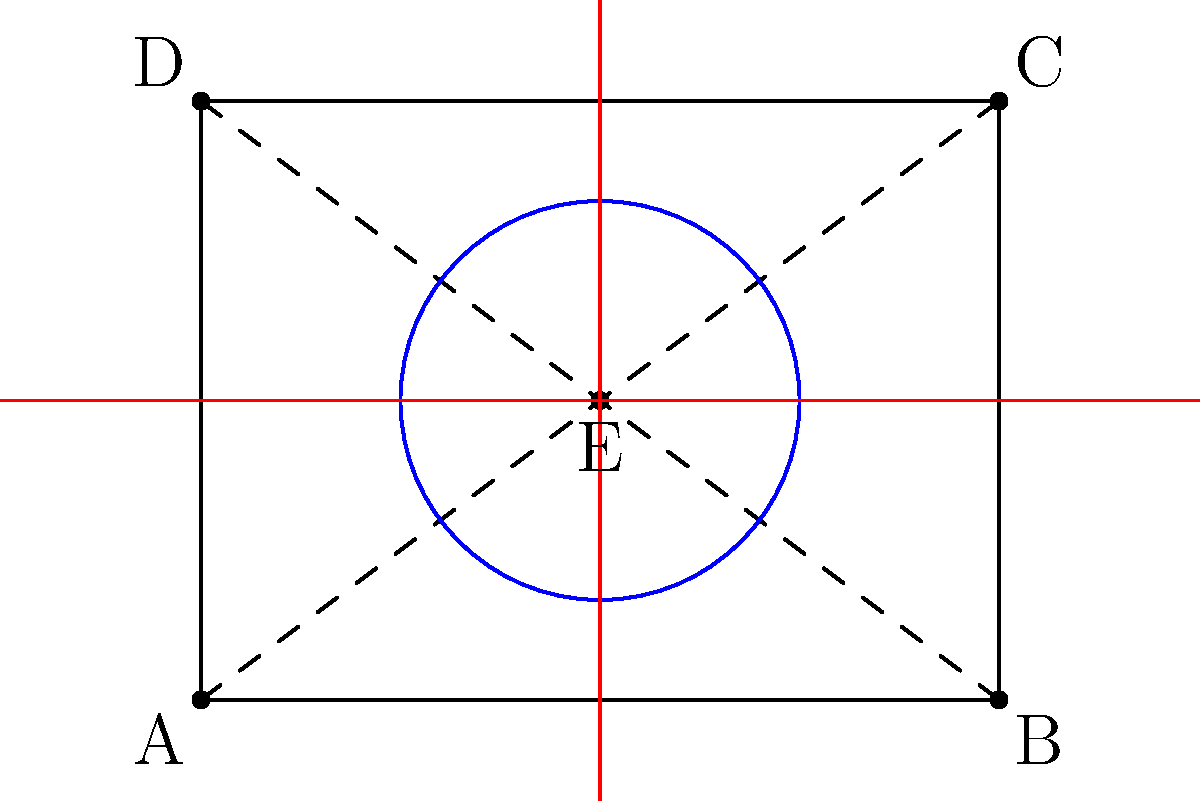For your music video set design, you want to create a dynamic effect using a rotating stage. The stage is represented by the rectangle ABCD, with point E at its center. You plan to rotate the stage 90° clockwise, then reflect it across the vertical line through E, and finally translate it 2 units up. What will be the final coordinates of point A after these transformations? Let's approach this step-by-step:

1) Initial coordinates:
   A(0,0), B(4,0), C(4,3), D(0,3), E(2,1.5)

2) Rotation by 90° clockwise around E(2,1.5):
   - The rotation matrix for 90° clockwise is:
     $$R = \begin{pmatrix} \cos(-90°) & -\sin(-90°) \\ \sin(-90°) & \cos(-90°) \end{pmatrix} = \begin{pmatrix} 0 & 1 \\ -1 & 0 \end{pmatrix}$$
   - Translate A to origin: (0-2, 0-1.5) = (-2, -1.5)
   - Apply rotation: $$\begin{pmatrix} 0 & 1 \\ -1 & 0 \end{pmatrix} \begin{pmatrix} -2 \\ -1.5 \end{pmatrix} = \begin{pmatrix} -1.5 \\ 2 \end{pmatrix}$$
   - Translate back: (-1.5+2, 2+1.5) = (0.5, 3.5)

3) Reflection across the vertical line through E (x = 2):
   - The new x-coordinate will be: 2 + (2 - 0.5) = 3.5
   - A is now at (3.5, 3.5)

4) Translation 2 units up:
   - Add 2 to the y-coordinate
   - A is now at (3.5, 5.5)

Therefore, the final coordinates of point A are (3.5, 5.5).
Answer: (3.5, 5.5) 